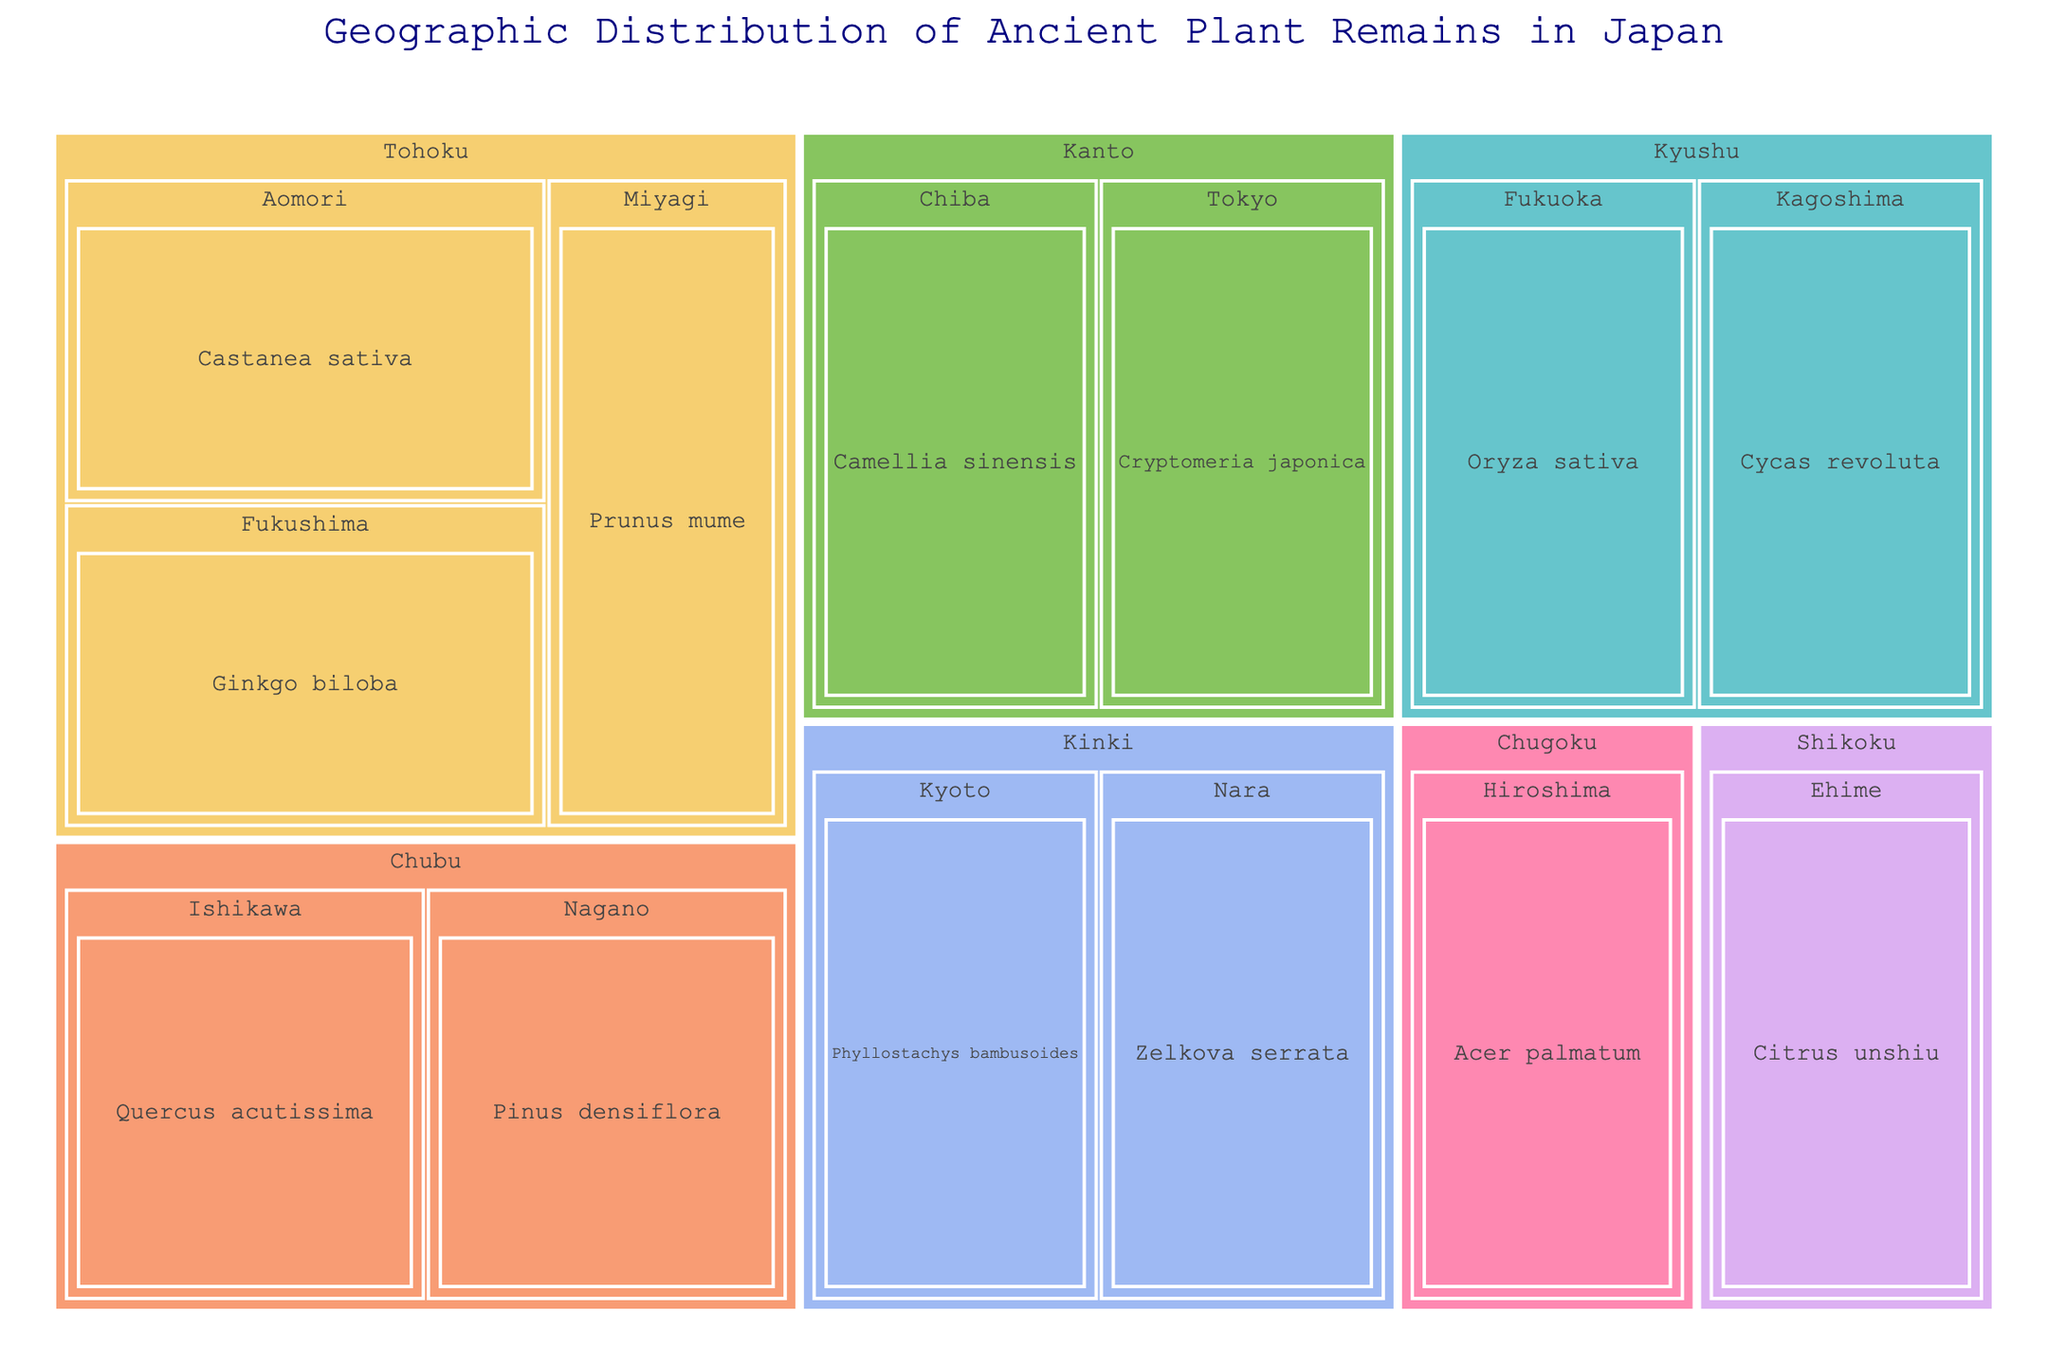what is the title of the figure? The title is often prominently displayed and is usually at the top of the figure. In this case, it is set in the 'title' parameter of the plot.
Answer: Geographic Distribution of Ancient Plant Remains in Japan Which region has the plant remains "Cryptomeria japonica"? By looking at the regions and their respective plant remains, "Cryptomeria japonica" is listed under the region shown in the treemap.
Answer: Kanto How many plant remains are found in the Tohoku region? By counting the unique plant remains listed under the Tohoku region as shown in the treemap.
Answer: 3 Are there more plant remains in the Chubu region or the Kyushu region? By comparing the number of plant remains listed under each of these regions in the treemap.
Answer: Kyushu Which region contains the plant remains "Oryza sativa"? By finding "Oryza sativa" in the treemap and noting the region it belongs to.
Answer: Kyushu How many regions are represented in the figure? By counting the unique regions displayed in the treemap.
Answer: 7 What plant remains are found in the Kinki region? By looking at the areas listed under the Kinki region and noting their respective plant remains.
Answer: Phyllostachys bambusoides, Zelkova serrata Is the diversity of plant remains in the Shikoku region greater than in the Kanto region? By comparing the number of unique plant remains listed for both regions in the treemap. Shikoku has 1, Kanto has 2.
Answer: No What type of plant is found in Nagano within the Chubu region? By locating Nagano in the Chubu region in the treemap and noting its plant remains.
Answer: Pinus densiflora Do the regions with single plant remains have any specific color pattern in the treemap? Observing the color scheme used in the treemap for regions with single plant remains.
Answer: No specific pattern 